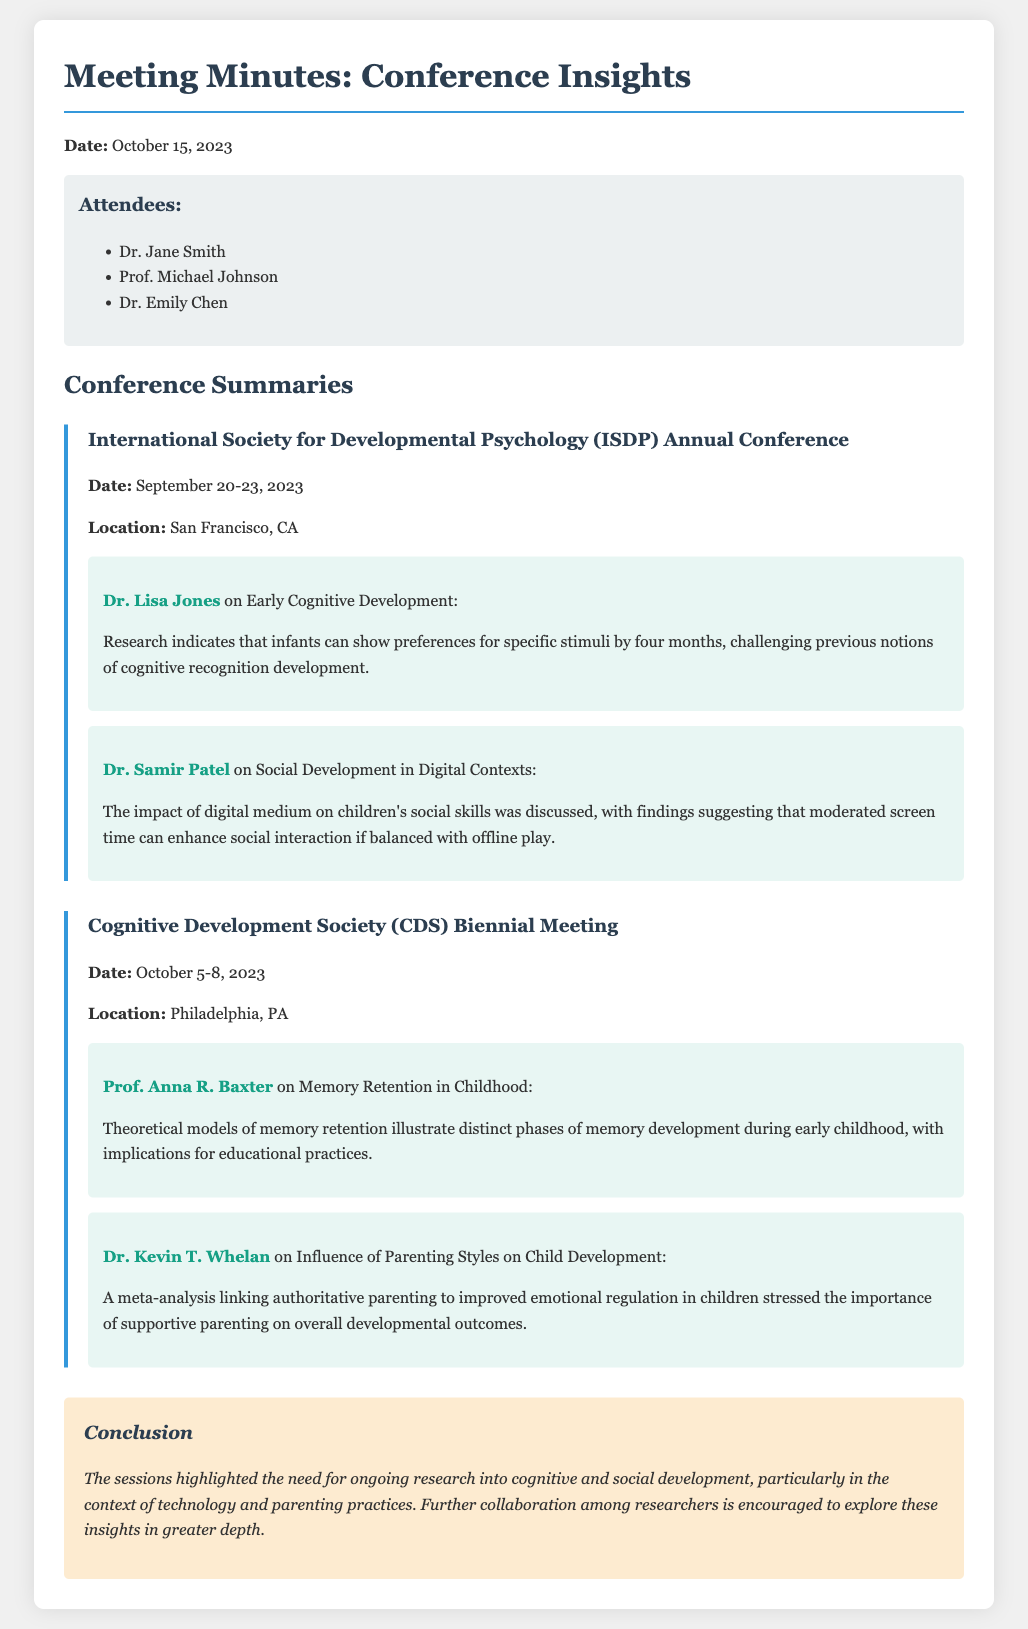What is the date of the ISDP Annual Conference? The date is specified in the document as September 20-23, 2023.
Answer: September 20-23, 2023 Who presented on Early Cognitive Development at the ISDP conference? The document mentions Dr. Lisa Jones as the speaker on this topic.
Answer: Dr. Lisa Jones What is the key insight regarding digital contexts discussed by Dr. Samir Patel? Dr. Samir Patel discussed the impact of moderated screen time on children's social interaction.
Answer: Moderated screen time can enhance social interaction What did Prof. Anna R. Baxter present on at the CDS meeting? The document states that she presented on memory retention in childhood and its implications.
Answer: Memory retention in childhood How many attendees are listed in the meeting minutes? The document lists three attendees by name.
Answer: Three What key theme emerges from the conclusion of the meeting minutes? The conclusion emphasizes ongoing research needs in cognitive and social development.
Answer: Ongoing research into cognitive and social development What location hosted the Cognitive Development Society Biennial Meeting? The document indicates that Philadelphia, PA was the location.
Answer: Philadelphia, PA What type of analysis did Dr. Kevin T. Whelan conduct regarding parenting styles? The document mentions a meta-analysis linking authoritative parenting to emotional regulation.
Answer: Meta-analysis 